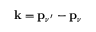<formula> <loc_0><loc_0><loc_500><loc_500>k = { p } _ { \nu ^ { \prime } } - { p _ { \nu } }</formula> 